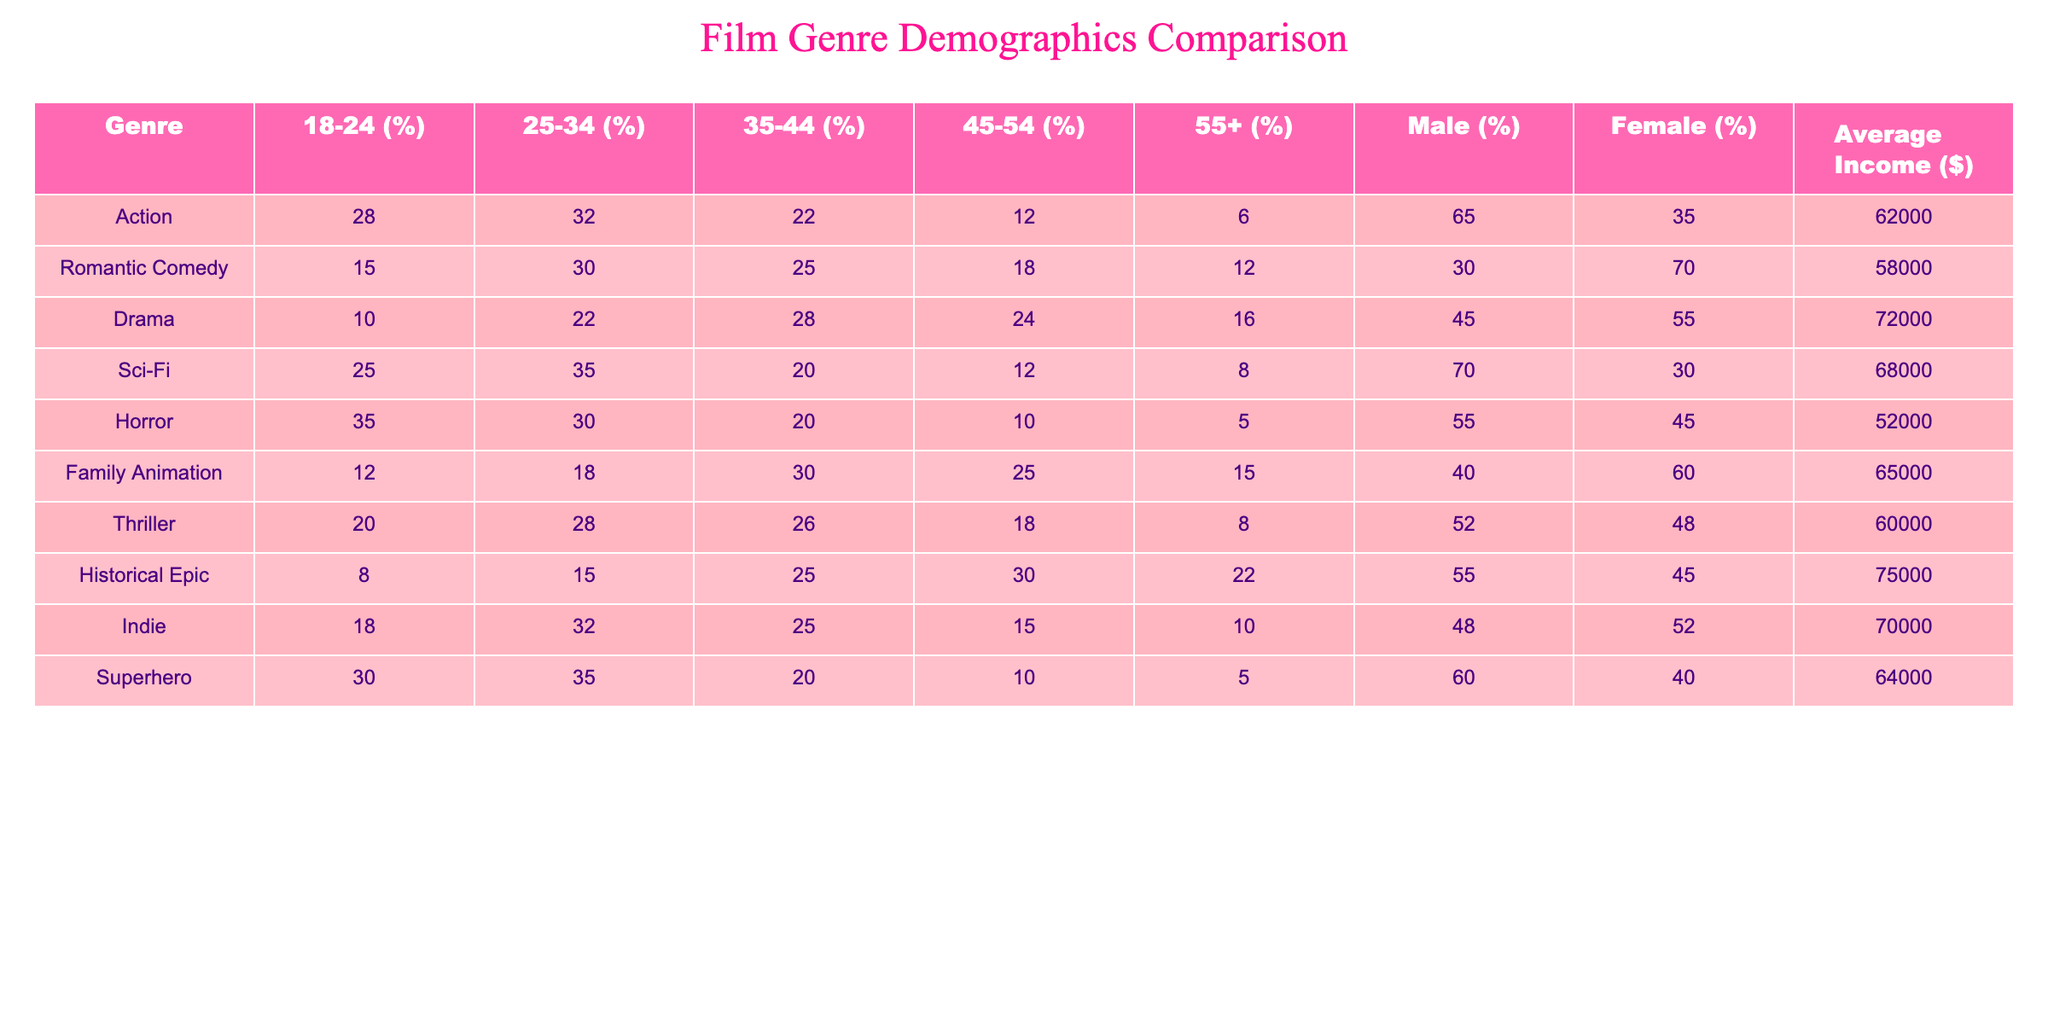What percentage of the audience for Romantic Comedy is aged 55 and above? According to the table, the percentage of the audience aged 55 and above for Romantic Comedy is listed as 12%.
Answer: 12% Which genre has the highest percentage of male viewers? Looking at the percentages for male viewers across all genres, Action has the highest at 65%.
Answer: 65% What is the average income of the audience for Drama? The average income for the audience of the Drama genre is provided in the table as $72,000.
Answer: 72000 How many genres have a higher than average percentage of viewers aged 25-34, where 'average' is defined as the mean of the 5 genres? The percentages for the 25-34 age group across genres are Action 32%, Romantic Comedy 30%, Drama 22%, Sci-Fi 35%, Horror 30%, Family Animation 18%, Thriller 28%, Historical Epic 15%, Indie 32%, and Superhero 35%. The average of these values is 26%. The genres with higher than 26% are Action, Romantic Comedy, Sci-Fi, Horror, Indie, and Superhero, totaling 6 genres.
Answer: 6 Is it true that the audience for Family Animation has a higher percentage of female viewers than the audience for Action? The percentage of female viewers for Family Animation is 60%, while for Action it is 35%, meaning Family Animation has a higher percentage of female viewers. Therefore, this statement is true.
Answer: Yes 